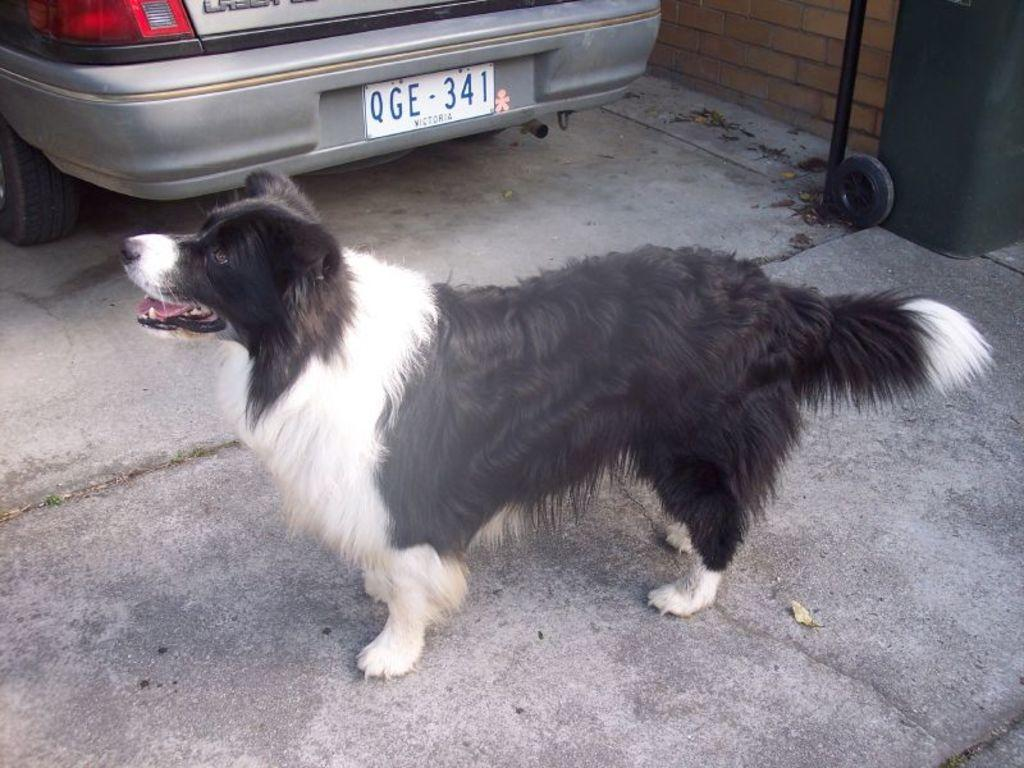What is the main subject in the middle of the image? There is a dog in the middle of the image. What can be seen at the top of the image? There is a vehicle at the top of the image. Can you describe the bin located in the top right-hand side of the image? There is a bin with wheels in the top right-hand side of the image. What type of lamp can be seen in the image? There is no lamp present in the image. How does the nerve affect the dog's behavior in the image? There is no mention of a nerve or any behavioral aspect related to the dog in the image. 